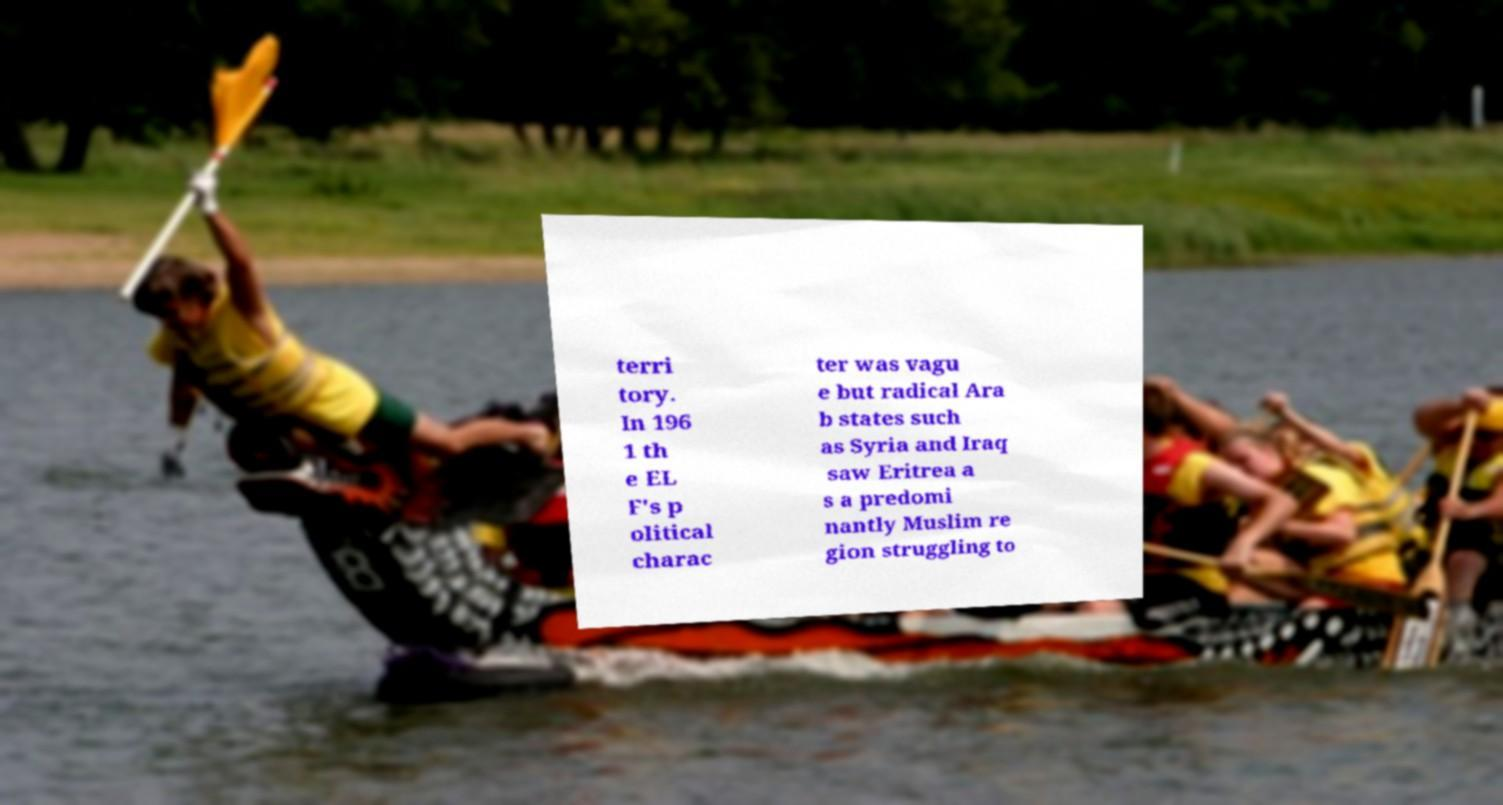Can you read and provide the text displayed in the image?This photo seems to have some interesting text. Can you extract and type it out for me? terri tory. In 196 1 th e EL F's p olitical charac ter was vagu e but radical Ara b states such as Syria and Iraq saw Eritrea a s a predomi nantly Muslim re gion struggling to 